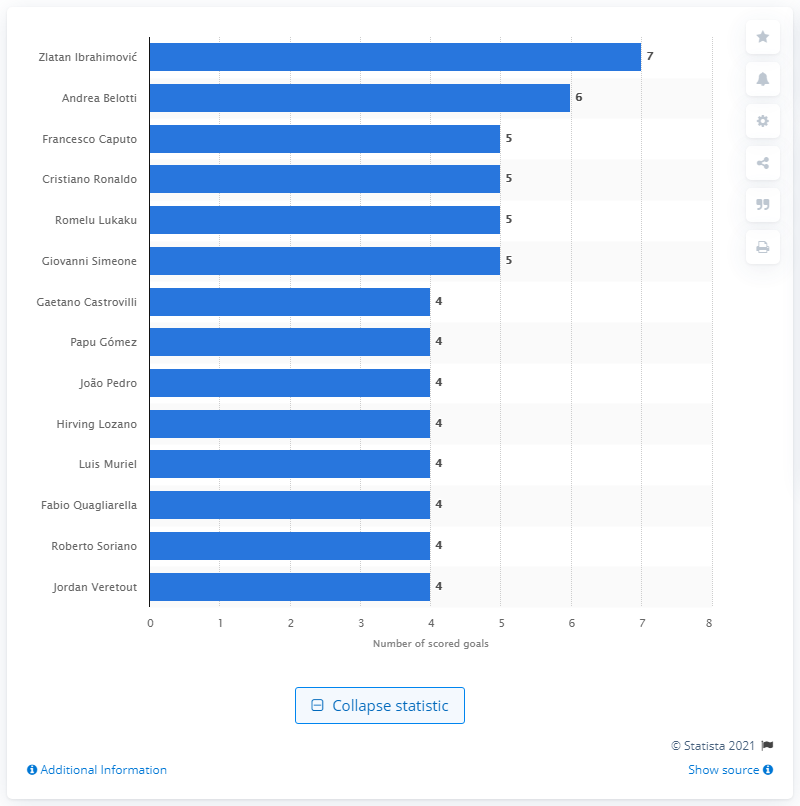Specify some key components in this picture. It is confirmed that Andrea Belotti, a player for Torino FC, scored a remarkable six goals in a recent match. 